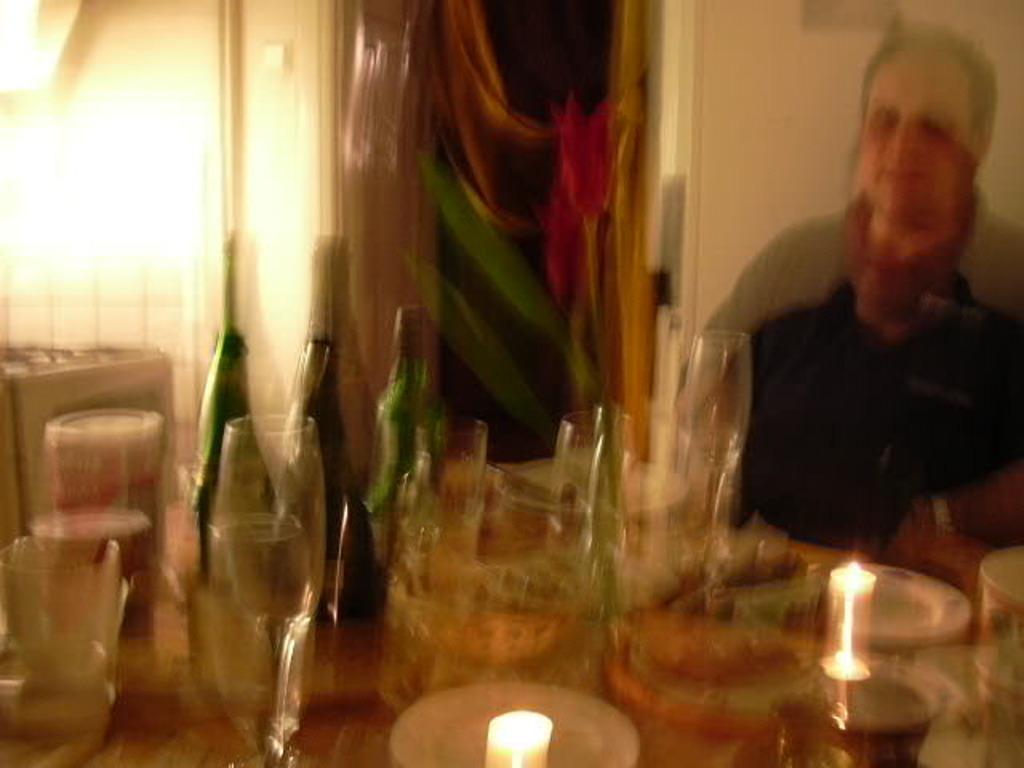How would you summarize this image in a sentence or two? In the image there is a dining table with wine glasses,bottles,bowls and candles on it, over the right side there is a man sitting in front of it, in the back there is wall. 